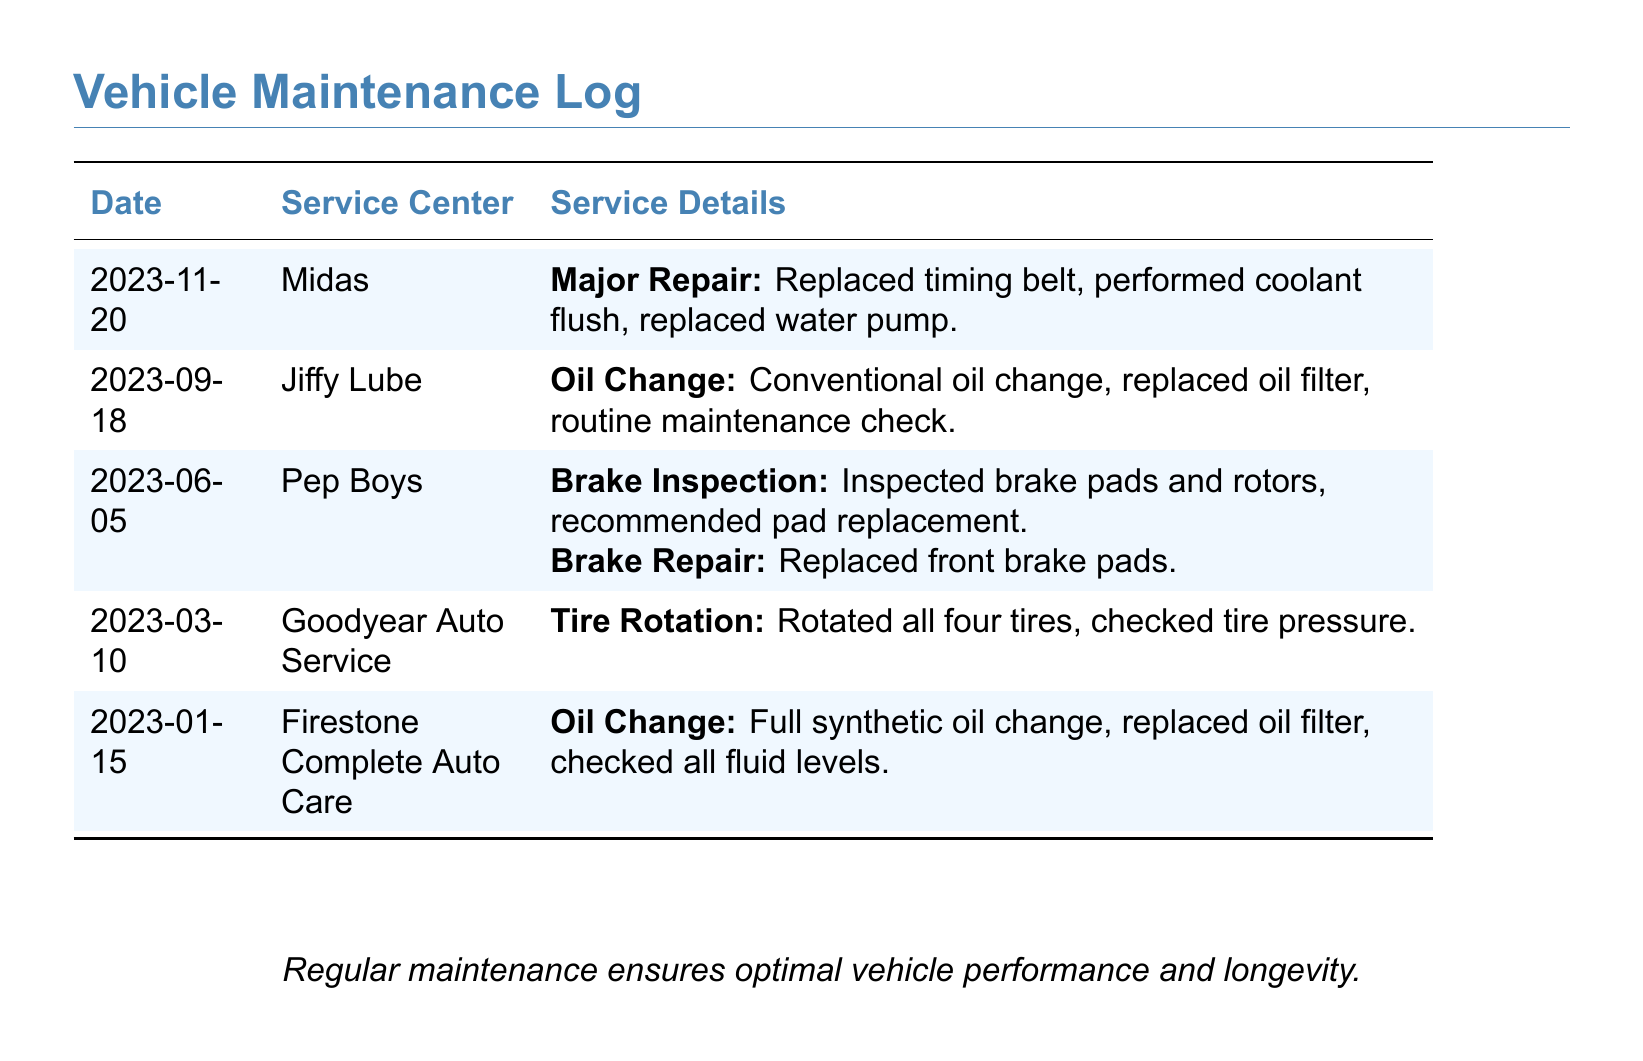What was the date of the major repair? The major repair was recorded on November 20, 2023.
Answer: 2023-11-20 Which service center performed the last oil change? The last oil change was performed at Firestone Complete Auto Care on January 15, 2023.
Answer: Firestone Complete Auto Care How many tire rotations are listed in the log? There is one tire rotation listed on March 10, 2023.
Answer: One What service was recommended during the brake inspection? The brake inspection recommended pad replacement after inspecting brake pads and rotors.
Answer: Pad replacement Which maintenance task was performed on June 5, 2023? On June 5, 2023, a brake inspection was performed, along with a brake repair that included replacing front brake pads.
Answer: Brake Inspection and Brake Repair What type of oil was used during the oil change on September 18, 2023? The oil change on September 18, 2023, used conventional oil.
Answer: Conventional oil How many major repairs are recorded in the maintenance log? There is one major repair recorded on November 20, 2023.
Answer: One What additional service was performed along with the major repair? Along with the major repair, a coolant flush and a water pump replacement were performed.
Answer: Coolant flush, water pump replacement What was checked during the tire rotation service? During the tire rotation service, tire pressure was checked.
Answer: Tire pressure 